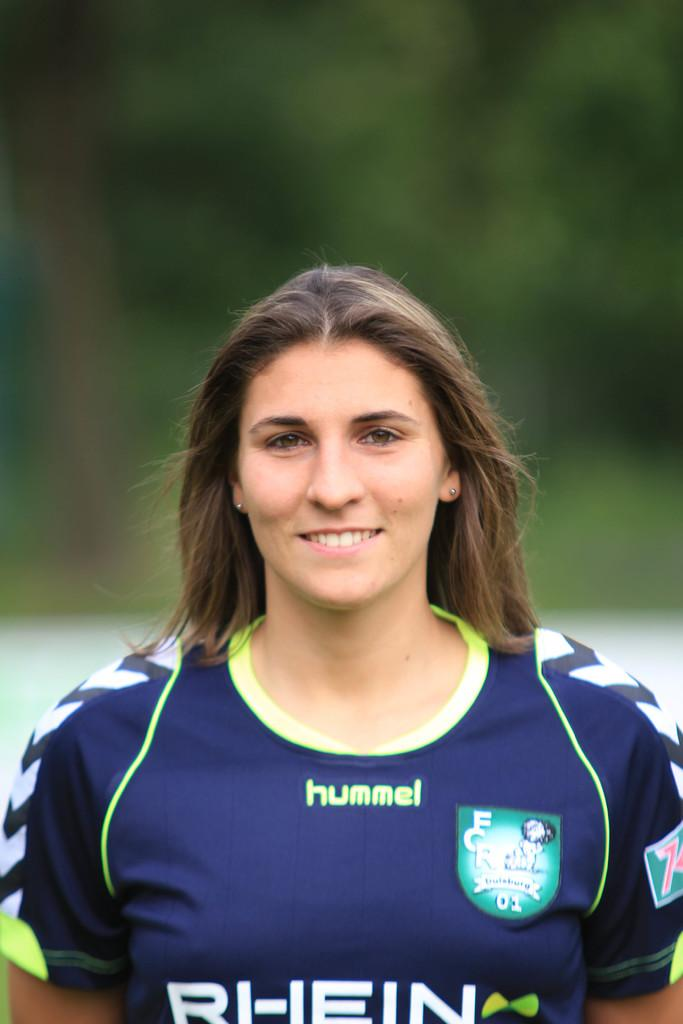<image>
Offer a succinct explanation of the picture presented. Woman is wearing a blue and yellow shirt that reads hummel Rhein. 